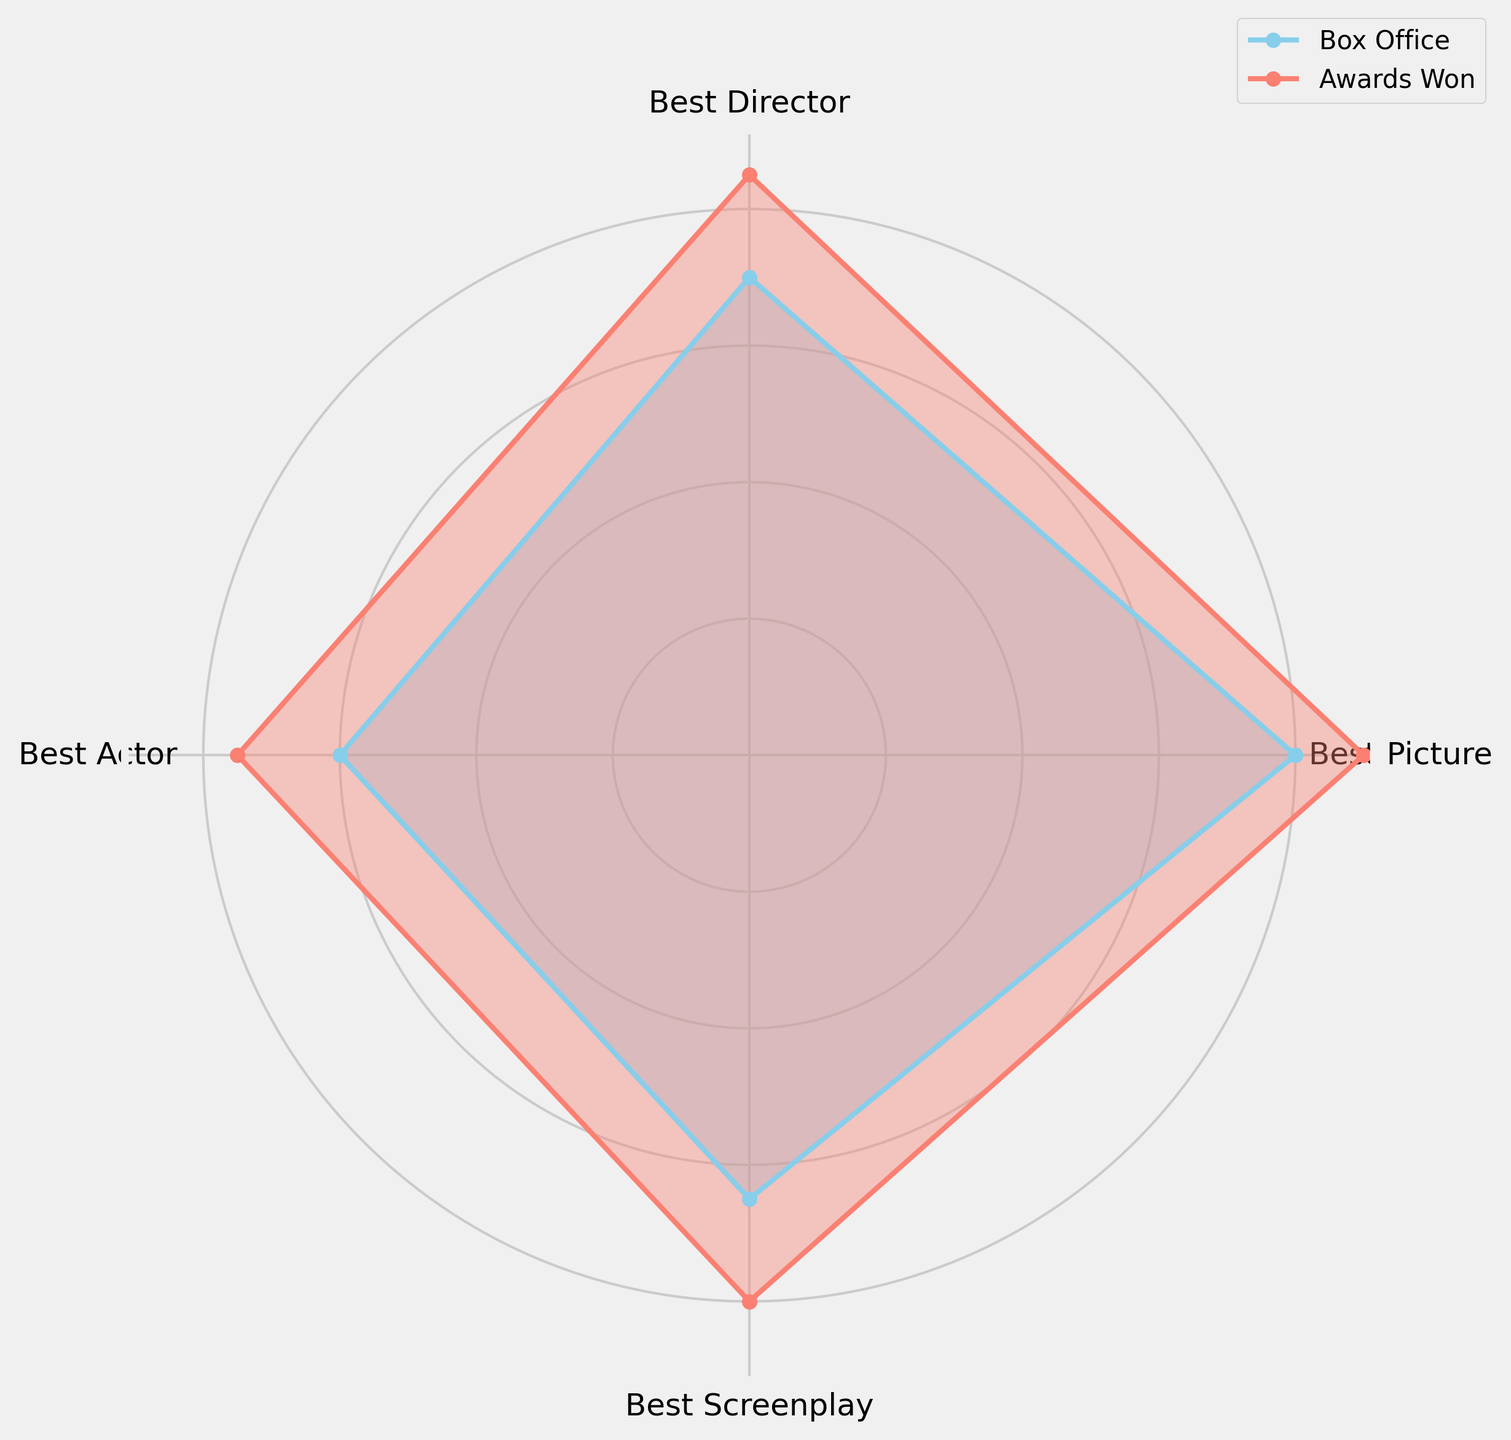Which category shows the highest box office performance? By observing the radar chart, identify the category that has the highest value along the "Box Office" line.
Answer: Best Picture Which category has the largest difference between box office performance and awards won? Calculate the difference between "Box Office" and "Awards Won" for each category and compare them. Best Picture (0.8, 0.9), Best Director (0.7, 0.85), Best Actor (0.6, 0.75), Best Screenplay (0.65, 0.8). The differences are 0.1, 0.15, 0.15, 0.15 respectively. Best Picture has the smallest difference.
Answer: Best Director, Best Actor, Best Screenplay Is the box office performance higher than awards won for any category? Compare the "Box Office" and "Awards Won" values for each category. In all cases, Awards Won is higher.
Answer: No Which categories have higher awards won compared to box office performance? Identify the categories where the value of "Awards Won" exceeds "Box Office." Check all categories: Best Picture, Best Director, Best Actor, Best Screenplay; all fit this criterion.
Answer: All categories What's the average box office performance across all categories? Sum the box office performance values (0.8, 0.7, 0.6, 0.65) and divide by the number of categories (4). (0.8 + 0.7 + 0.6 + 0.65) / 4 = 0.6875
Answer: 0.6875 Which category shows the lowest awards won? By observing the radar chart, identify the category that has the lowest value along the "Awards Won" line.
Answer: Best Actor Which two categories have the closest values for both box office performance and awards won? Compare the values for both "Box Office" and "Awards Won" for all combinations of categories and identify the two categories with the smallest differences. Best Actor: (0.6, 0.75) & Best Screenplay: (0.65, 0.8) have the smallest differences (0.05, 0.05).
Answer: Best Actor and Best Screenplay What's the total awards won if you sum the values across all categories? Sum the awards won values (0.9, 0.85, 0.75, 0.8). 0.9 + 0.85 + 0.75 + 0.8 = 3.3
Answer: 3.3 What's the difference between the highest and lowest box office performances? Find the highest (0.8 for Best Picture) and lowest (0.6 for Best Actor) values and subtract them. 0.8 - 0.6 = 0.2
Answer: 0.2 